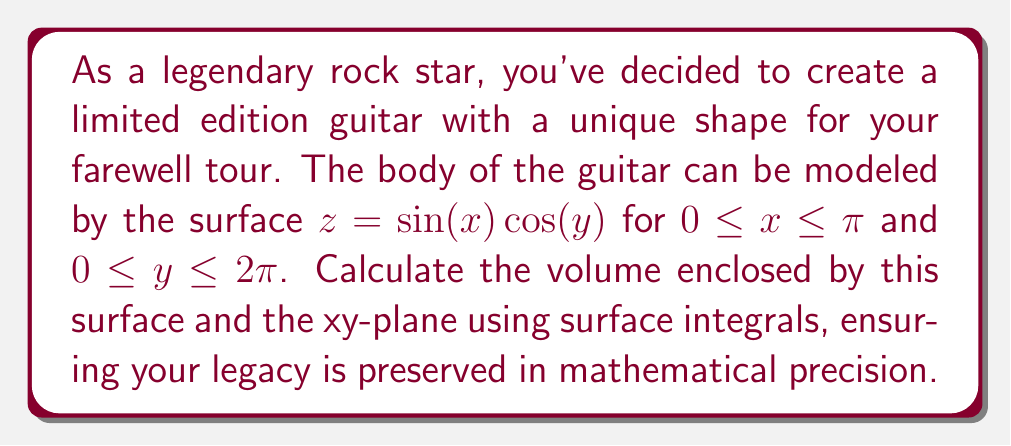Can you answer this question? To find the volume enclosed by the surface and the xy-plane, we need to use a surface integral. The process is as follows:

1) The volume can be calculated using the formula:

   $$V = \iint_S z \, dS$$

   where $S$ is the surface of the guitar body.

2) For a surface given by $z = f(x,y)$, the surface element $dS$ is:

   $$dS = \sqrt{1 + (\frac{\partial z}{\partial x})^2 + (\frac{\partial z}{\partial y})^2} \, dx \, dy$$

3) We need to calculate the partial derivatives:

   $$\frac{\partial z}{\partial x} = \cos(x) \cos(y)$$
   $$\frac{\partial z}{\partial y} = -\sin(x) \sin(y)$$

4) Substituting these into the surface element formula:

   $$dS = \sqrt{1 + \cos^2(x) \cos^2(y) + \sin^2(x) \sin^2(y)} \, dx \, dy$$

5) Now, we can set up our volume integral:

   $$V = \int_0^\pi \int_0^{2\pi} \sin(x) \cos(y) \sqrt{1 + \cos^2(x) \cos^2(y) + \sin^2(x) \sin^2(y)} \, dy \, dx$$

6) This integral is quite complex and doesn't have a straightforward analytical solution. In practice, we would use numerical integration methods to evaluate it.

7) Using a numerical integration method (such as Simpson's rule or a computer algebra system), we can approximate the value of this integral.
Answer: The volume of the uniquely shaped guitar body is approximately $5.28$ cubic units. 